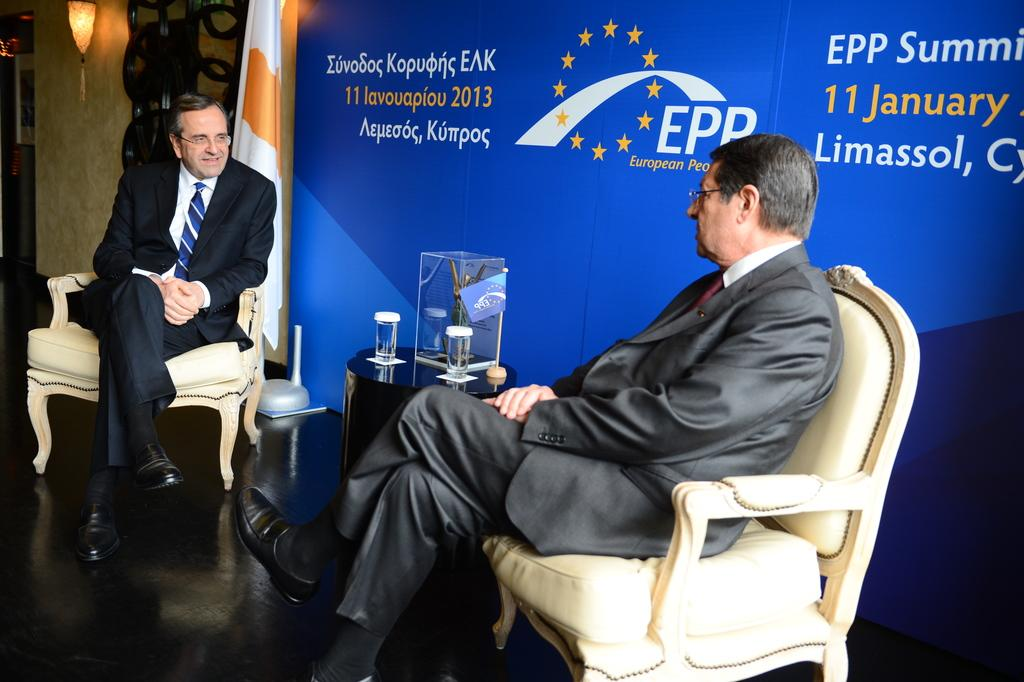How many people are in the image? There are two men in the image. What are the men doing in the image? The men are sitting on chairs. What is the facial expression of one of the men? One of the men is smiling. What is the other man doing in the image? The other man is looking at the smiling man. What additional objects can be seen in the image? There is a flag and a banner in the image. What type of jellyfish can be seen floating in the background of the image? There are no jellyfish present in the image; it features two men sitting on chairs. Can you tell me what flavor of jam is on the smiling man's sandwich? There is no sandwich or jam present in the image. 